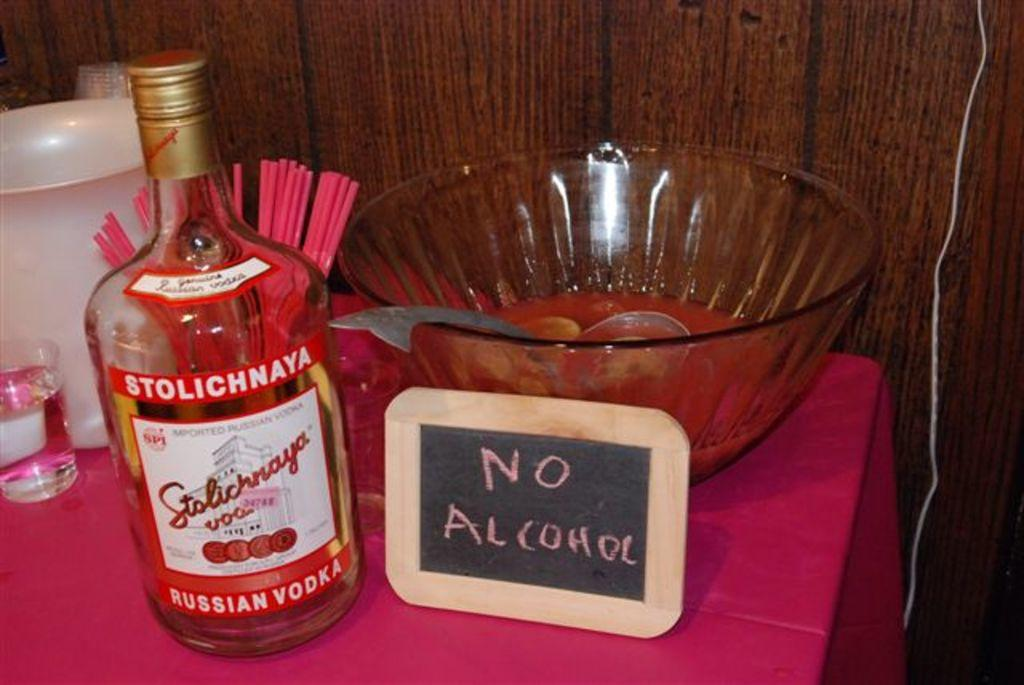<image>
Give a short and clear explanation of the subsequent image. A bottle of Stolichnaya Russian Bodka on a table with a pinch bowl with a sign in front of the bowl that says No Alcohol. 